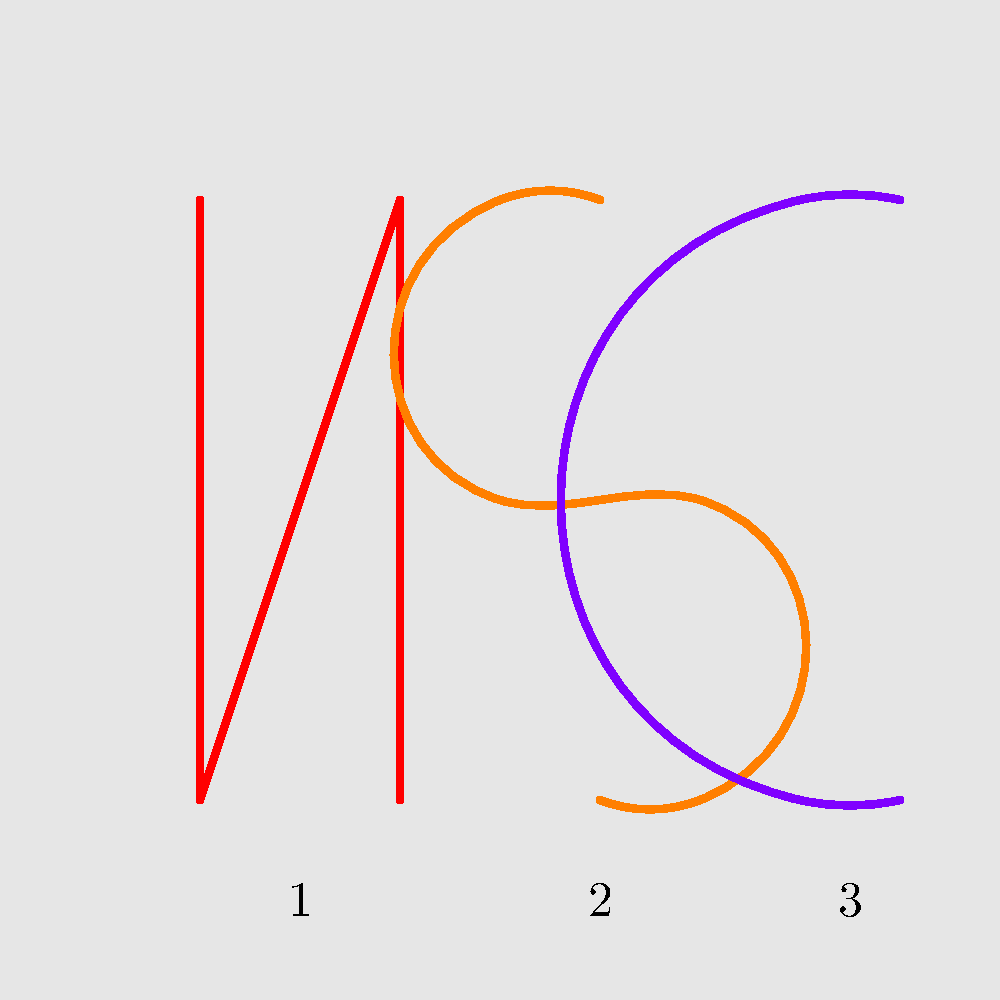Based on the simplified logo designs shown above, which number corresponds to the logo of the popular Netflix original series "Stranger Things"? To answer this question, let's analyze each logo and relate it to popular Netflix original series:

1. Logo 1 (red): This is a simplified version of the Netflix "N" logo. It's not specific to any particular series.

2. Logo 2 (orange): This "S" shaped logo is a simplified version of the "Stranger Things" logo. The show's actual logo features a distinctive, retro-style "S" that resembles this simplified version.

3. Logo 3 (purple): This "C" shaped logo doesn't correspond to any major Netflix original series that starts with C.

Given the persona of a college student who watches Netflix but doesn't follow entertainment news closely, they might recognize the distinctive "S" logo from "Stranger Things" as it's one of Netflix's most popular and widely marketed original series.

The correct answer is logo number 2, which represents the simplified version of the "Stranger Things" logo.
Answer: 2 